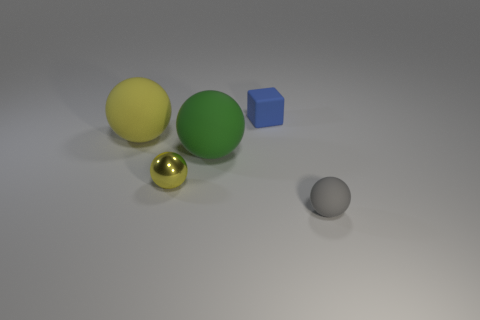There is another gray object that is the same shape as the metal object; what is it made of?
Offer a very short reply. Rubber. What is the size of the rubber thing that is the same color as the tiny metallic ball?
Give a very brief answer. Large. Are there any matte things of the same color as the small shiny object?
Make the answer very short. Yes. Is the color of the small metal sphere the same as the sphere that is behind the large green matte sphere?
Your response must be concise. Yes. There is a rubber ball left of the green matte ball; is it the same color as the tiny metallic object?
Your answer should be very brief. Yes. Is there any other thing that has the same material as the large green thing?
Keep it short and to the point. Yes. Does the green matte thing have the same shape as the tiny rubber object that is behind the big yellow matte object?
Offer a terse response. No. What number of other objects are there of the same size as the yellow metallic sphere?
Your answer should be compact. 2. What number of cyan things are large spheres or small rubber cubes?
Your answer should be very brief. 0. How many matte things are on the right side of the yellow shiny object and behind the gray rubber object?
Offer a terse response. 2. 